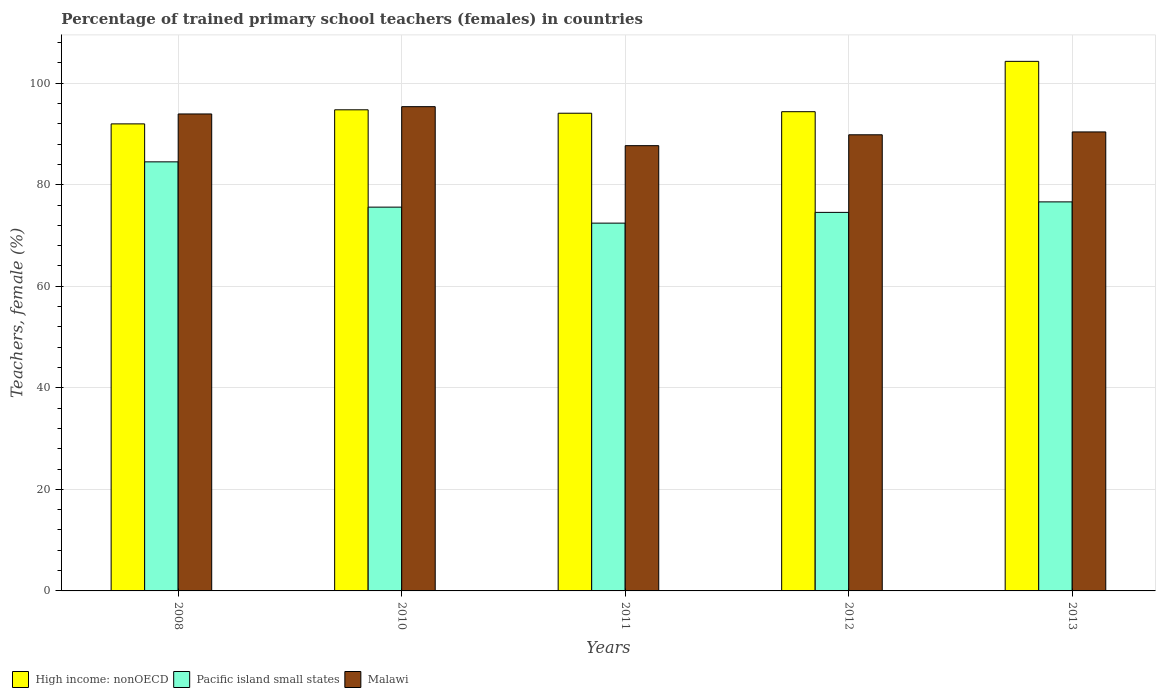How many groups of bars are there?
Your response must be concise. 5. Are the number of bars per tick equal to the number of legend labels?
Make the answer very short. Yes. Are the number of bars on each tick of the X-axis equal?
Provide a short and direct response. Yes. How many bars are there on the 4th tick from the left?
Provide a succinct answer. 3. How many bars are there on the 4th tick from the right?
Give a very brief answer. 3. In how many cases, is the number of bars for a given year not equal to the number of legend labels?
Provide a succinct answer. 0. What is the percentage of trained primary school teachers (females) in Pacific island small states in 2012?
Your response must be concise. 74.55. Across all years, what is the maximum percentage of trained primary school teachers (females) in Malawi?
Keep it short and to the point. 95.38. Across all years, what is the minimum percentage of trained primary school teachers (females) in Pacific island small states?
Give a very brief answer. 72.44. In which year was the percentage of trained primary school teachers (females) in High income: nonOECD minimum?
Make the answer very short. 2008. What is the total percentage of trained primary school teachers (females) in High income: nonOECD in the graph?
Offer a terse response. 479.52. What is the difference between the percentage of trained primary school teachers (females) in Malawi in 2008 and that in 2012?
Offer a very short reply. 4.1. What is the difference between the percentage of trained primary school teachers (females) in High income: nonOECD in 2010 and the percentage of trained primary school teachers (females) in Pacific island small states in 2012?
Your response must be concise. 20.2. What is the average percentage of trained primary school teachers (females) in High income: nonOECD per year?
Make the answer very short. 95.9. In the year 2013, what is the difference between the percentage of trained primary school teachers (females) in Malawi and percentage of trained primary school teachers (females) in High income: nonOECD?
Provide a short and direct response. -13.9. What is the ratio of the percentage of trained primary school teachers (females) in Pacific island small states in 2010 to that in 2011?
Your response must be concise. 1.04. What is the difference between the highest and the second highest percentage of trained primary school teachers (females) in Pacific island small states?
Offer a very short reply. 7.88. What is the difference between the highest and the lowest percentage of trained primary school teachers (females) in Malawi?
Make the answer very short. 7.68. In how many years, is the percentage of trained primary school teachers (females) in Pacific island small states greater than the average percentage of trained primary school teachers (females) in Pacific island small states taken over all years?
Provide a short and direct response. 1. What does the 1st bar from the left in 2013 represents?
Your answer should be compact. High income: nonOECD. What does the 1st bar from the right in 2013 represents?
Make the answer very short. Malawi. How many bars are there?
Offer a terse response. 15. How many years are there in the graph?
Provide a succinct answer. 5. What is the difference between two consecutive major ticks on the Y-axis?
Your answer should be compact. 20. Does the graph contain grids?
Provide a short and direct response. Yes. Where does the legend appear in the graph?
Your answer should be compact. Bottom left. How many legend labels are there?
Give a very brief answer. 3. What is the title of the graph?
Offer a very short reply. Percentage of trained primary school teachers (females) in countries. What is the label or title of the Y-axis?
Provide a succinct answer. Teachers, female (%). What is the Teachers, female (%) of High income: nonOECD in 2008?
Your answer should be very brief. 91.99. What is the Teachers, female (%) of Pacific island small states in 2008?
Your answer should be compact. 84.51. What is the Teachers, female (%) in Malawi in 2008?
Offer a terse response. 93.94. What is the Teachers, female (%) of High income: nonOECD in 2010?
Provide a succinct answer. 94.76. What is the Teachers, female (%) of Pacific island small states in 2010?
Offer a very short reply. 75.59. What is the Teachers, female (%) of Malawi in 2010?
Offer a very short reply. 95.38. What is the Teachers, female (%) of High income: nonOECD in 2011?
Make the answer very short. 94.08. What is the Teachers, female (%) in Pacific island small states in 2011?
Provide a short and direct response. 72.44. What is the Teachers, female (%) of Malawi in 2011?
Your answer should be very brief. 87.7. What is the Teachers, female (%) in High income: nonOECD in 2012?
Your response must be concise. 94.39. What is the Teachers, female (%) in Pacific island small states in 2012?
Keep it short and to the point. 74.55. What is the Teachers, female (%) in Malawi in 2012?
Your response must be concise. 89.84. What is the Teachers, female (%) of High income: nonOECD in 2013?
Make the answer very short. 104.3. What is the Teachers, female (%) in Pacific island small states in 2013?
Your response must be concise. 76.62. What is the Teachers, female (%) of Malawi in 2013?
Your response must be concise. 90.4. Across all years, what is the maximum Teachers, female (%) in High income: nonOECD?
Your answer should be compact. 104.3. Across all years, what is the maximum Teachers, female (%) of Pacific island small states?
Your answer should be very brief. 84.51. Across all years, what is the maximum Teachers, female (%) of Malawi?
Provide a short and direct response. 95.38. Across all years, what is the minimum Teachers, female (%) in High income: nonOECD?
Your response must be concise. 91.99. Across all years, what is the minimum Teachers, female (%) of Pacific island small states?
Offer a terse response. 72.44. Across all years, what is the minimum Teachers, female (%) in Malawi?
Provide a succinct answer. 87.7. What is the total Teachers, female (%) in High income: nonOECD in the graph?
Make the answer very short. 479.52. What is the total Teachers, female (%) in Pacific island small states in the graph?
Offer a terse response. 383.72. What is the total Teachers, female (%) of Malawi in the graph?
Provide a short and direct response. 457.26. What is the difference between the Teachers, female (%) in High income: nonOECD in 2008 and that in 2010?
Offer a very short reply. -2.77. What is the difference between the Teachers, female (%) in Pacific island small states in 2008 and that in 2010?
Provide a succinct answer. 8.92. What is the difference between the Teachers, female (%) of Malawi in 2008 and that in 2010?
Ensure brevity in your answer.  -1.43. What is the difference between the Teachers, female (%) in High income: nonOECD in 2008 and that in 2011?
Provide a succinct answer. -2.1. What is the difference between the Teachers, female (%) in Pacific island small states in 2008 and that in 2011?
Provide a short and direct response. 12.07. What is the difference between the Teachers, female (%) in Malawi in 2008 and that in 2011?
Your response must be concise. 6.24. What is the difference between the Teachers, female (%) of High income: nonOECD in 2008 and that in 2012?
Your answer should be very brief. -2.4. What is the difference between the Teachers, female (%) in Pacific island small states in 2008 and that in 2012?
Your response must be concise. 9.95. What is the difference between the Teachers, female (%) of Malawi in 2008 and that in 2012?
Give a very brief answer. 4.1. What is the difference between the Teachers, female (%) of High income: nonOECD in 2008 and that in 2013?
Provide a succinct answer. -12.32. What is the difference between the Teachers, female (%) in Pacific island small states in 2008 and that in 2013?
Keep it short and to the point. 7.88. What is the difference between the Teachers, female (%) in Malawi in 2008 and that in 2013?
Your answer should be compact. 3.54. What is the difference between the Teachers, female (%) in High income: nonOECD in 2010 and that in 2011?
Offer a terse response. 0.67. What is the difference between the Teachers, female (%) in Pacific island small states in 2010 and that in 2011?
Give a very brief answer. 3.15. What is the difference between the Teachers, female (%) in Malawi in 2010 and that in 2011?
Your response must be concise. 7.68. What is the difference between the Teachers, female (%) of High income: nonOECD in 2010 and that in 2012?
Make the answer very short. 0.37. What is the difference between the Teachers, female (%) of Pacific island small states in 2010 and that in 2012?
Provide a short and direct response. 1.04. What is the difference between the Teachers, female (%) of Malawi in 2010 and that in 2012?
Give a very brief answer. 5.54. What is the difference between the Teachers, female (%) in High income: nonOECD in 2010 and that in 2013?
Provide a short and direct response. -9.54. What is the difference between the Teachers, female (%) of Pacific island small states in 2010 and that in 2013?
Ensure brevity in your answer.  -1.03. What is the difference between the Teachers, female (%) in Malawi in 2010 and that in 2013?
Make the answer very short. 4.97. What is the difference between the Teachers, female (%) in High income: nonOECD in 2011 and that in 2012?
Your answer should be compact. -0.3. What is the difference between the Teachers, female (%) of Pacific island small states in 2011 and that in 2012?
Give a very brief answer. -2.12. What is the difference between the Teachers, female (%) in Malawi in 2011 and that in 2012?
Your answer should be compact. -2.14. What is the difference between the Teachers, female (%) in High income: nonOECD in 2011 and that in 2013?
Give a very brief answer. -10.22. What is the difference between the Teachers, female (%) of Pacific island small states in 2011 and that in 2013?
Offer a very short reply. -4.18. What is the difference between the Teachers, female (%) of Malawi in 2011 and that in 2013?
Offer a terse response. -2.7. What is the difference between the Teachers, female (%) in High income: nonOECD in 2012 and that in 2013?
Your answer should be compact. -9.91. What is the difference between the Teachers, female (%) in Pacific island small states in 2012 and that in 2013?
Provide a succinct answer. -2.07. What is the difference between the Teachers, female (%) in Malawi in 2012 and that in 2013?
Give a very brief answer. -0.56. What is the difference between the Teachers, female (%) in High income: nonOECD in 2008 and the Teachers, female (%) in Pacific island small states in 2010?
Offer a terse response. 16.39. What is the difference between the Teachers, female (%) of High income: nonOECD in 2008 and the Teachers, female (%) of Malawi in 2010?
Offer a terse response. -3.39. What is the difference between the Teachers, female (%) of Pacific island small states in 2008 and the Teachers, female (%) of Malawi in 2010?
Offer a terse response. -10.87. What is the difference between the Teachers, female (%) of High income: nonOECD in 2008 and the Teachers, female (%) of Pacific island small states in 2011?
Provide a succinct answer. 19.55. What is the difference between the Teachers, female (%) in High income: nonOECD in 2008 and the Teachers, female (%) in Malawi in 2011?
Provide a succinct answer. 4.29. What is the difference between the Teachers, female (%) in Pacific island small states in 2008 and the Teachers, female (%) in Malawi in 2011?
Give a very brief answer. -3.19. What is the difference between the Teachers, female (%) in High income: nonOECD in 2008 and the Teachers, female (%) in Pacific island small states in 2012?
Keep it short and to the point. 17.43. What is the difference between the Teachers, female (%) in High income: nonOECD in 2008 and the Teachers, female (%) in Malawi in 2012?
Your answer should be compact. 2.15. What is the difference between the Teachers, female (%) in Pacific island small states in 2008 and the Teachers, female (%) in Malawi in 2012?
Your response must be concise. -5.33. What is the difference between the Teachers, female (%) of High income: nonOECD in 2008 and the Teachers, female (%) of Pacific island small states in 2013?
Make the answer very short. 15.36. What is the difference between the Teachers, female (%) of High income: nonOECD in 2008 and the Teachers, female (%) of Malawi in 2013?
Your answer should be compact. 1.58. What is the difference between the Teachers, female (%) of Pacific island small states in 2008 and the Teachers, female (%) of Malawi in 2013?
Give a very brief answer. -5.89. What is the difference between the Teachers, female (%) of High income: nonOECD in 2010 and the Teachers, female (%) of Pacific island small states in 2011?
Make the answer very short. 22.32. What is the difference between the Teachers, female (%) in High income: nonOECD in 2010 and the Teachers, female (%) in Malawi in 2011?
Ensure brevity in your answer.  7.06. What is the difference between the Teachers, female (%) of Pacific island small states in 2010 and the Teachers, female (%) of Malawi in 2011?
Provide a short and direct response. -12.11. What is the difference between the Teachers, female (%) in High income: nonOECD in 2010 and the Teachers, female (%) in Pacific island small states in 2012?
Your response must be concise. 20.2. What is the difference between the Teachers, female (%) of High income: nonOECD in 2010 and the Teachers, female (%) of Malawi in 2012?
Your answer should be very brief. 4.92. What is the difference between the Teachers, female (%) in Pacific island small states in 2010 and the Teachers, female (%) in Malawi in 2012?
Your response must be concise. -14.25. What is the difference between the Teachers, female (%) of High income: nonOECD in 2010 and the Teachers, female (%) of Pacific island small states in 2013?
Give a very brief answer. 18.13. What is the difference between the Teachers, female (%) in High income: nonOECD in 2010 and the Teachers, female (%) in Malawi in 2013?
Your response must be concise. 4.36. What is the difference between the Teachers, female (%) in Pacific island small states in 2010 and the Teachers, female (%) in Malawi in 2013?
Keep it short and to the point. -14.81. What is the difference between the Teachers, female (%) in High income: nonOECD in 2011 and the Teachers, female (%) in Pacific island small states in 2012?
Your answer should be very brief. 19.53. What is the difference between the Teachers, female (%) in High income: nonOECD in 2011 and the Teachers, female (%) in Malawi in 2012?
Offer a terse response. 4.25. What is the difference between the Teachers, female (%) of Pacific island small states in 2011 and the Teachers, female (%) of Malawi in 2012?
Offer a very short reply. -17.4. What is the difference between the Teachers, female (%) of High income: nonOECD in 2011 and the Teachers, female (%) of Pacific island small states in 2013?
Keep it short and to the point. 17.46. What is the difference between the Teachers, female (%) in High income: nonOECD in 2011 and the Teachers, female (%) in Malawi in 2013?
Your answer should be compact. 3.68. What is the difference between the Teachers, female (%) in Pacific island small states in 2011 and the Teachers, female (%) in Malawi in 2013?
Your response must be concise. -17.96. What is the difference between the Teachers, female (%) in High income: nonOECD in 2012 and the Teachers, female (%) in Pacific island small states in 2013?
Your answer should be very brief. 17.76. What is the difference between the Teachers, female (%) in High income: nonOECD in 2012 and the Teachers, female (%) in Malawi in 2013?
Your answer should be compact. 3.99. What is the difference between the Teachers, female (%) in Pacific island small states in 2012 and the Teachers, female (%) in Malawi in 2013?
Offer a terse response. -15.85. What is the average Teachers, female (%) in High income: nonOECD per year?
Give a very brief answer. 95.9. What is the average Teachers, female (%) in Pacific island small states per year?
Your answer should be compact. 76.74. What is the average Teachers, female (%) in Malawi per year?
Your answer should be very brief. 91.45. In the year 2008, what is the difference between the Teachers, female (%) of High income: nonOECD and Teachers, female (%) of Pacific island small states?
Make the answer very short. 7.48. In the year 2008, what is the difference between the Teachers, female (%) in High income: nonOECD and Teachers, female (%) in Malawi?
Your response must be concise. -1.96. In the year 2008, what is the difference between the Teachers, female (%) of Pacific island small states and Teachers, female (%) of Malawi?
Your response must be concise. -9.43. In the year 2010, what is the difference between the Teachers, female (%) of High income: nonOECD and Teachers, female (%) of Pacific island small states?
Your answer should be compact. 19.17. In the year 2010, what is the difference between the Teachers, female (%) of High income: nonOECD and Teachers, female (%) of Malawi?
Your answer should be compact. -0.62. In the year 2010, what is the difference between the Teachers, female (%) of Pacific island small states and Teachers, female (%) of Malawi?
Your answer should be compact. -19.79. In the year 2011, what is the difference between the Teachers, female (%) in High income: nonOECD and Teachers, female (%) in Pacific island small states?
Keep it short and to the point. 21.65. In the year 2011, what is the difference between the Teachers, female (%) in High income: nonOECD and Teachers, female (%) in Malawi?
Your answer should be very brief. 6.39. In the year 2011, what is the difference between the Teachers, female (%) in Pacific island small states and Teachers, female (%) in Malawi?
Offer a terse response. -15.26. In the year 2012, what is the difference between the Teachers, female (%) of High income: nonOECD and Teachers, female (%) of Pacific island small states?
Provide a succinct answer. 19.83. In the year 2012, what is the difference between the Teachers, female (%) of High income: nonOECD and Teachers, female (%) of Malawi?
Provide a short and direct response. 4.55. In the year 2012, what is the difference between the Teachers, female (%) in Pacific island small states and Teachers, female (%) in Malawi?
Offer a terse response. -15.28. In the year 2013, what is the difference between the Teachers, female (%) of High income: nonOECD and Teachers, female (%) of Pacific island small states?
Keep it short and to the point. 27.68. In the year 2013, what is the difference between the Teachers, female (%) in Pacific island small states and Teachers, female (%) in Malawi?
Offer a terse response. -13.78. What is the ratio of the Teachers, female (%) of High income: nonOECD in 2008 to that in 2010?
Offer a very short reply. 0.97. What is the ratio of the Teachers, female (%) in Pacific island small states in 2008 to that in 2010?
Offer a terse response. 1.12. What is the ratio of the Teachers, female (%) of Malawi in 2008 to that in 2010?
Ensure brevity in your answer.  0.98. What is the ratio of the Teachers, female (%) of High income: nonOECD in 2008 to that in 2011?
Your response must be concise. 0.98. What is the ratio of the Teachers, female (%) of Pacific island small states in 2008 to that in 2011?
Ensure brevity in your answer.  1.17. What is the ratio of the Teachers, female (%) in Malawi in 2008 to that in 2011?
Offer a very short reply. 1.07. What is the ratio of the Teachers, female (%) of High income: nonOECD in 2008 to that in 2012?
Offer a terse response. 0.97. What is the ratio of the Teachers, female (%) of Pacific island small states in 2008 to that in 2012?
Offer a very short reply. 1.13. What is the ratio of the Teachers, female (%) in Malawi in 2008 to that in 2012?
Your answer should be compact. 1.05. What is the ratio of the Teachers, female (%) of High income: nonOECD in 2008 to that in 2013?
Offer a very short reply. 0.88. What is the ratio of the Teachers, female (%) in Pacific island small states in 2008 to that in 2013?
Ensure brevity in your answer.  1.1. What is the ratio of the Teachers, female (%) in Malawi in 2008 to that in 2013?
Your answer should be compact. 1.04. What is the ratio of the Teachers, female (%) in Pacific island small states in 2010 to that in 2011?
Offer a terse response. 1.04. What is the ratio of the Teachers, female (%) in Malawi in 2010 to that in 2011?
Provide a succinct answer. 1.09. What is the ratio of the Teachers, female (%) of High income: nonOECD in 2010 to that in 2012?
Provide a short and direct response. 1. What is the ratio of the Teachers, female (%) of Pacific island small states in 2010 to that in 2012?
Your answer should be compact. 1.01. What is the ratio of the Teachers, female (%) in Malawi in 2010 to that in 2012?
Your response must be concise. 1.06. What is the ratio of the Teachers, female (%) in High income: nonOECD in 2010 to that in 2013?
Offer a very short reply. 0.91. What is the ratio of the Teachers, female (%) in Pacific island small states in 2010 to that in 2013?
Provide a short and direct response. 0.99. What is the ratio of the Teachers, female (%) in Malawi in 2010 to that in 2013?
Offer a very short reply. 1.05. What is the ratio of the Teachers, female (%) in High income: nonOECD in 2011 to that in 2012?
Offer a terse response. 1. What is the ratio of the Teachers, female (%) of Pacific island small states in 2011 to that in 2012?
Give a very brief answer. 0.97. What is the ratio of the Teachers, female (%) in Malawi in 2011 to that in 2012?
Your answer should be very brief. 0.98. What is the ratio of the Teachers, female (%) in High income: nonOECD in 2011 to that in 2013?
Offer a very short reply. 0.9. What is the ratio of the Teachers, female (%) of Pacific island small states in 2011 to that in 2013?
Make the answer very short. 0.95. What is the ratio of the Teachers, female (%) in Malawi in 2011 to that in 2013?
Provide a short and direct response. 0.97. What is the ratio of the Teachers, female (%) in High income: nonOECD in 2012 to that in 2013?
Offer a terse response. 0.91. What is the ratio of the Teachers, female (%) in Pacific island small states in 2012 to that in 2013?
Your answer should be compact. 0.97. What is the ratio of the Teachers, female (%) in Malawi in 2012 to that in 2013?
Make the answer very short. 0.99. What is the difference between the highest and the second highest Teachers, female (%) of High income: nonOECD?
Offer a terse response. 9.54. What is the difference between the highest and the second highest Teachers, female (%) in Pacific island small states?
Provide a succinct answer. 7.88. What is the difference between the highest and the second highest Teachers, female (%) in Malawi?
Keep it short and to the point. 1.43. What is the difference between the highest and the lowest Teachers, female (%) in High income: nonOECD?
Ensure brevity in your answer.  12.32. What is the difference between the highest and the lowest Teachers, female (%) in Pacific island small states?
Offer a very short reply. 12.07. What is the difference between the highest and the lowest Teachers, female (%) in Malawi?
Provide a succinct answer. 7.68. 